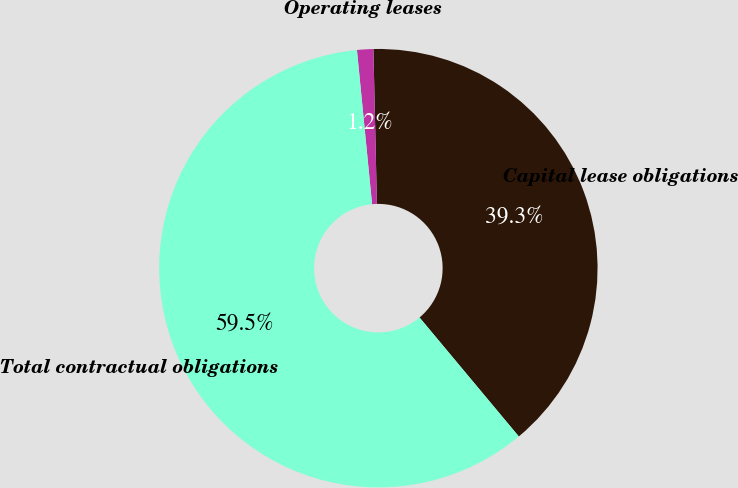Convert chart. <chart><loc_0><loc_0><loc_500><loc_500><pie_chart><fcel>Capital lease obligations<fcel>Operating leases<fcel>Total contractual obligations<nl><fcel>39.29%<fcel>1.2%<fcel>59.51%<nl></chart> 